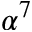<formula> <loc_0><loc_0><loc_500><loc_500>\alpha ^ { 7 }</formula> 